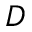Convert formula to latex. <formula><loc_0><loc_0><loc_500><loc_500>D</formula> 